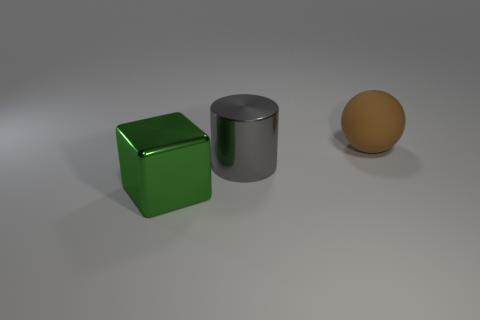Add 2 tiny cyan matte things. How many objects exist? 5 Subtract all cylinders. How many objects are left? 2 Subtract all gray metallic things. Subtract all large green rubber things. How many objects are left? 2 Add 2 big shiny cylinders. How many big shiny cylinders are left? 3 Add 3 large cylinders. How many large cylinders exist? 4 Subtract 0 brown cylinders. How many objects are left? 3 